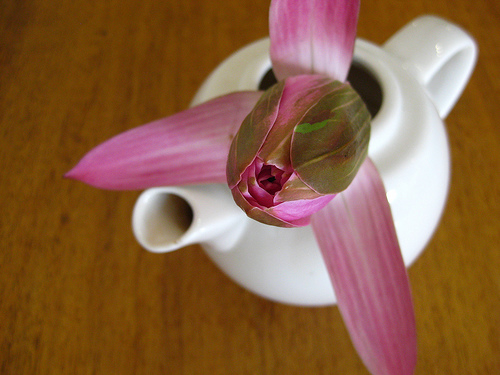<image>
Is the pot in the flower? No. The pot is not contained within the flower. These objects have a different spatial relationship. 